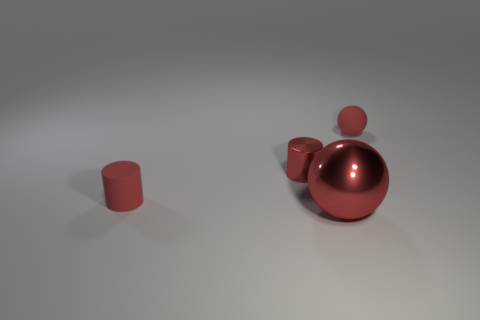Add 3 big brown metallic things. How many objects exist? 7 Add 1 small metal things. How many small metal things exist? 2 Subtract 0 gray blocks. How many objects are left? 4 Subtract 1 spheres. How many spheres are left? 1 Subtract all gray cylinders. Subtract all red balls. How many cylinders are left? 2 Subtract all small metallic cylinders. Subtract all tiny red shiny objects. How many objects are left? 2 Add 3 red spheres. How many red spheres are left? 5 